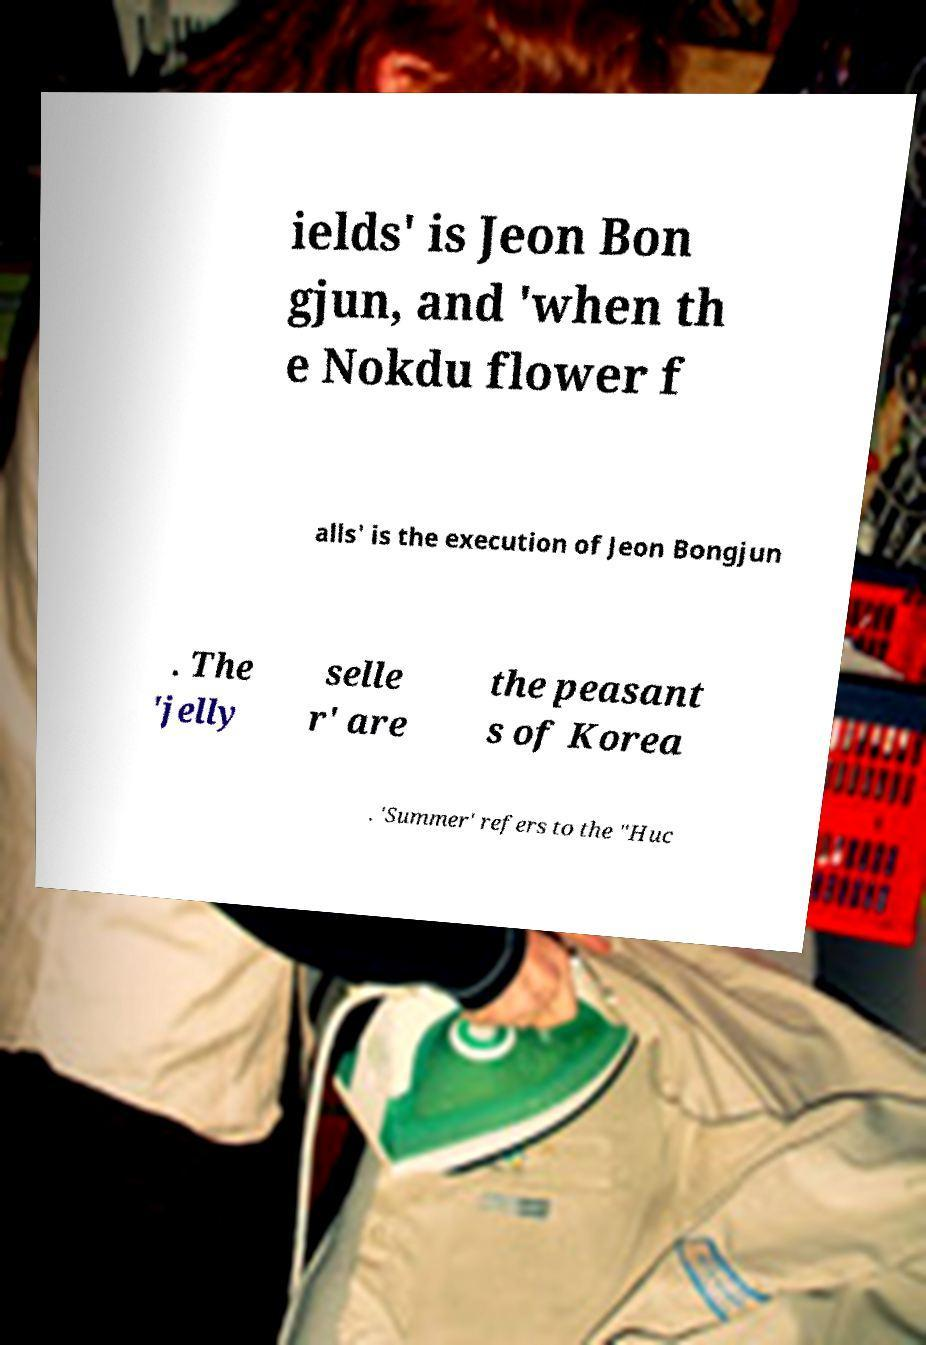What messages or text are displayed in this image? I need them in a readable, typed format. ields' is Jeon Bon gjun, and 'when th e Nokdu flower f alls' is the execution of Jeon Bongjun . The 'jelly selle r' are the peasant s of Korea . 'Summer' refers to the "Huc 